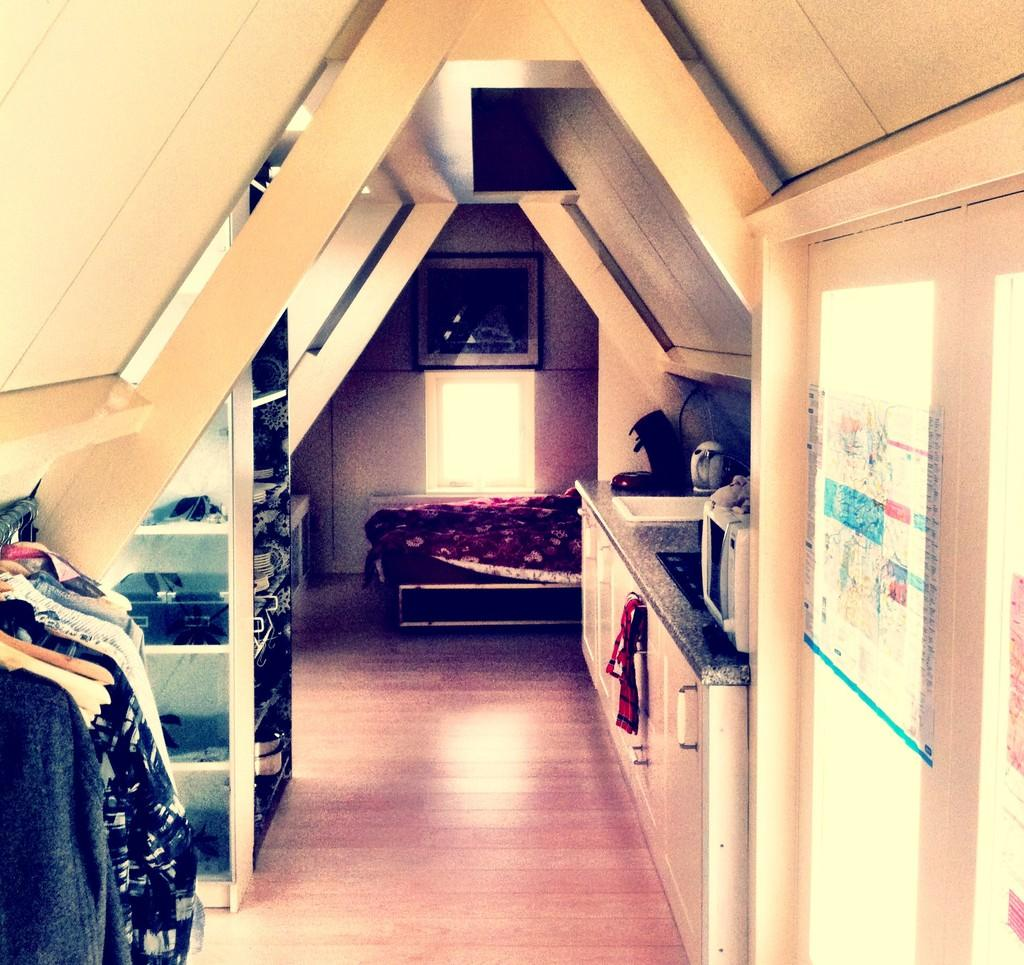What type of furniture is in the image? There is a bed in the image. Where is the bed located in the image? The bed is located in the top center of the image. What other object can be seen in the image? There is a sink in the image. What else is visible in the image besides the bed and sink? There are clothes visible in the image. How many lizards are crawling on the bed in the image? There are no lizards present in the image; it only features a bed, a sink, and clothes. 